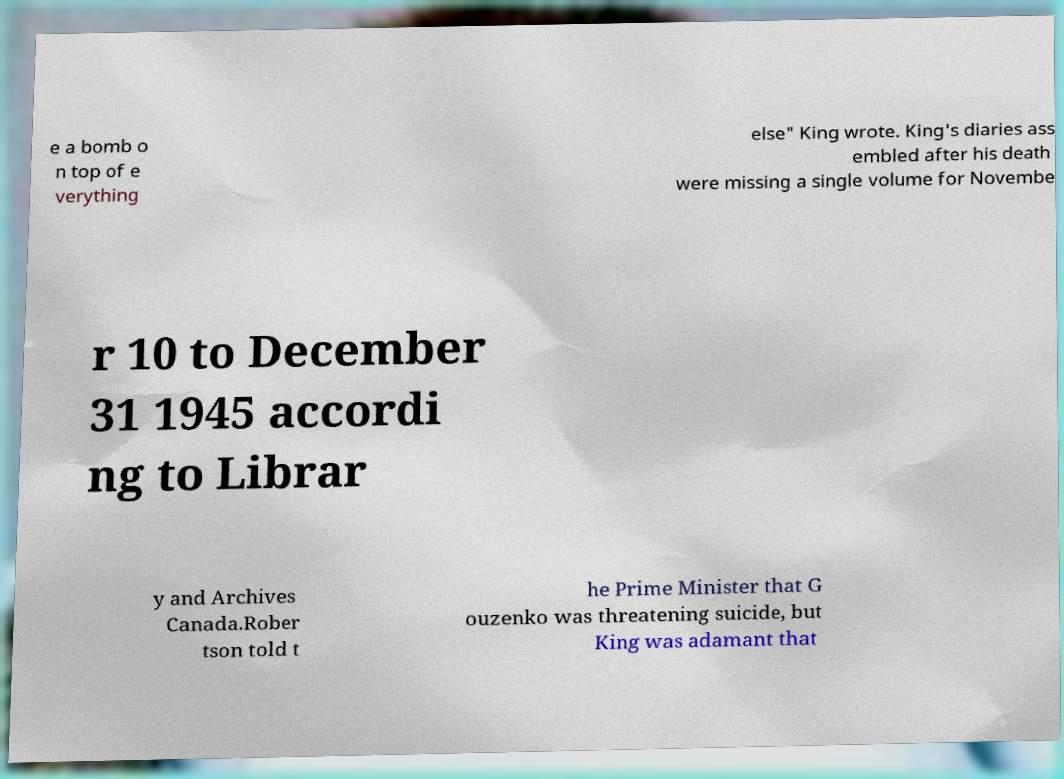Can you read and provide the text displayed in the image?This photo seems to have some interesting text. Can you extract and type it out for me? e a bomb o n top of e verything else" King wrote. King's diaries ass embled after his death were missing a single volume for Novembe r 10 to December 31 1945 accordi ng to Librar y and Archives Canada.Rober tson told t he Prime Minister that G ouzenko was threatening suicide, but King was adamant that 